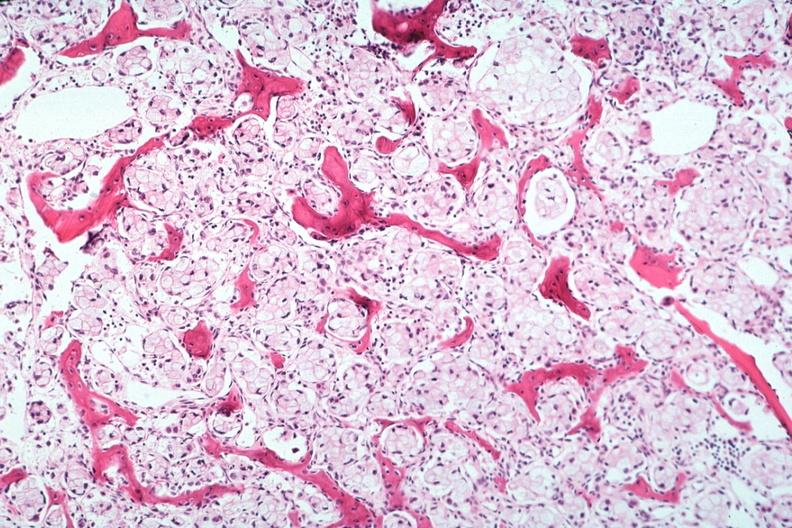does intrauterine contraceptive device show stomach primary?
Answer the question using a single word or phrase. No 